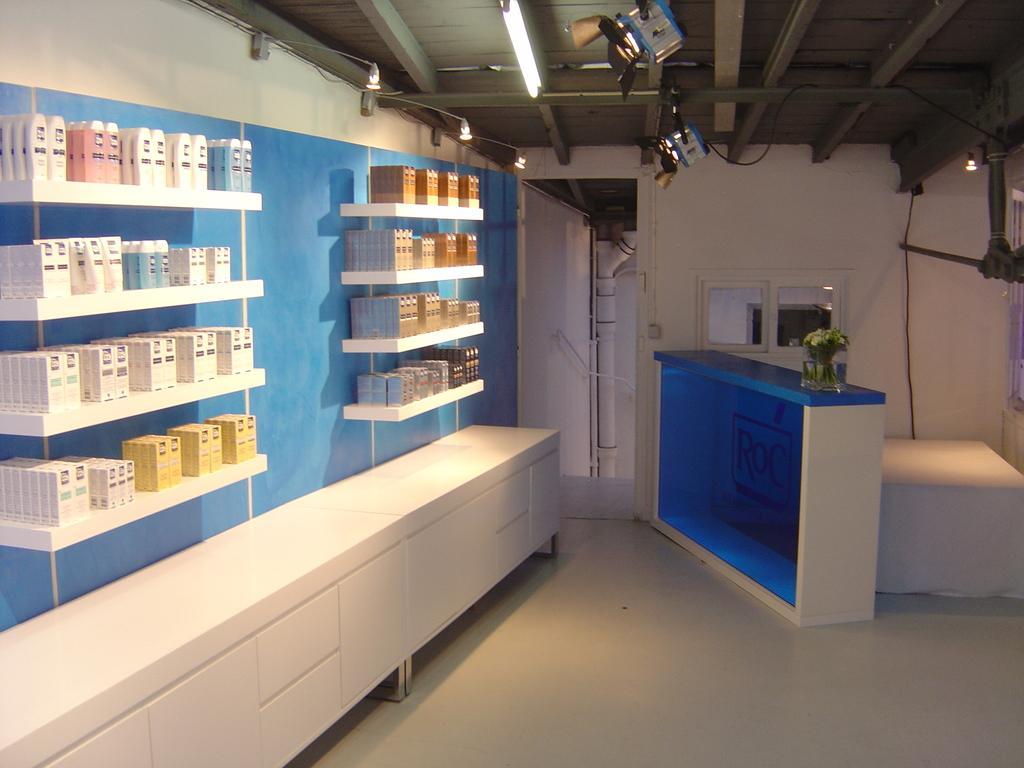Please provide a concise description of this image. This is a picture of a room, in this image on the left side there are some bottles and some packets in a cupboard. At the bottom there is one table and in the center there is a table, on the table there is one flower pot and plant and there is one chair. In the background there is a wall, mirrors and a pipe. At the top there is ceiling and some lights, and at the bottom of the image there is floor. 